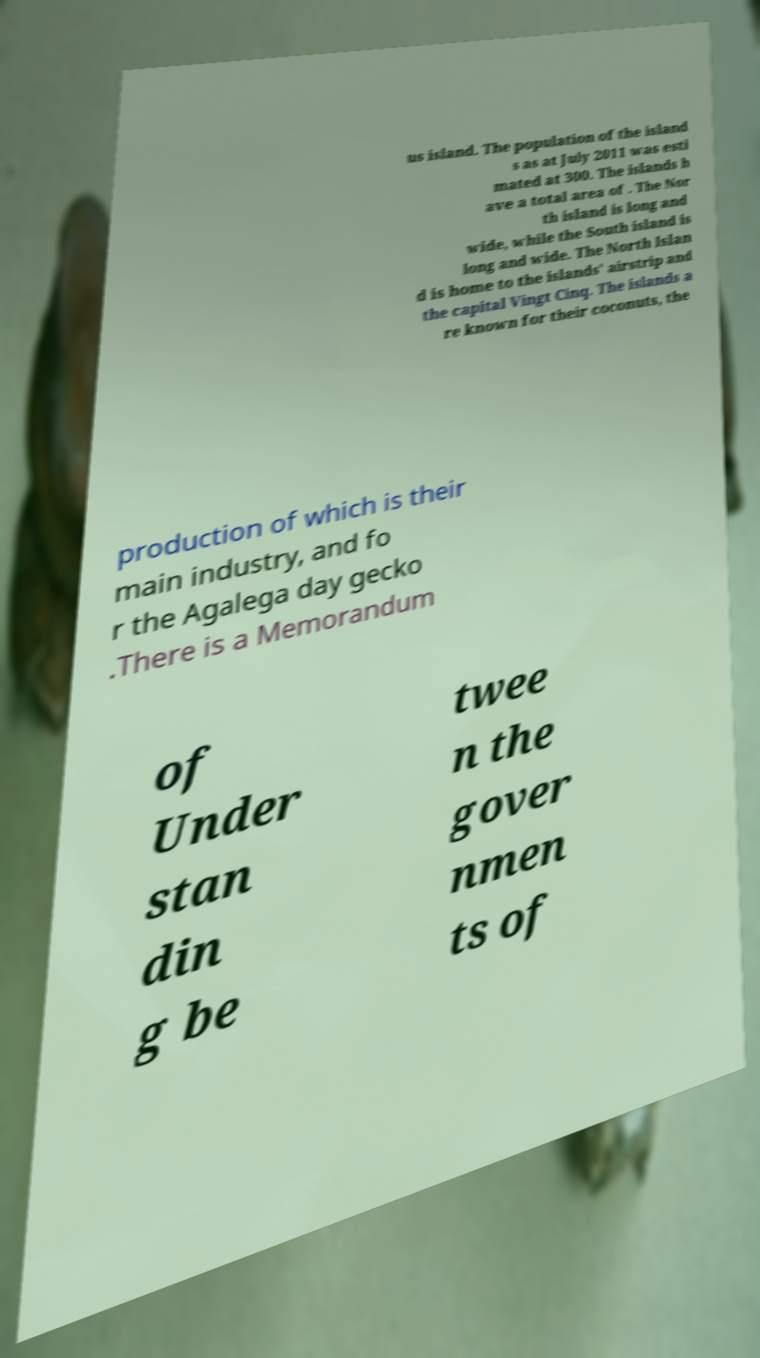Could you assist in decoding the text presented in this image and type it out clearly? us island. The population of the island s as at July 2011 was esti mated at 300. The islands h ave a total area of . The Nor th island is long and wide, while the South island is long and wide. The North Islan d is home to the islands' airstrip and the capital Vingt Cinq. The islands a re known for their coconuts, the production of which is their main industry, and fo r the Agalega day gecko .There is a Memorandum of Under stan din g be twee n the gover nmen ts of 